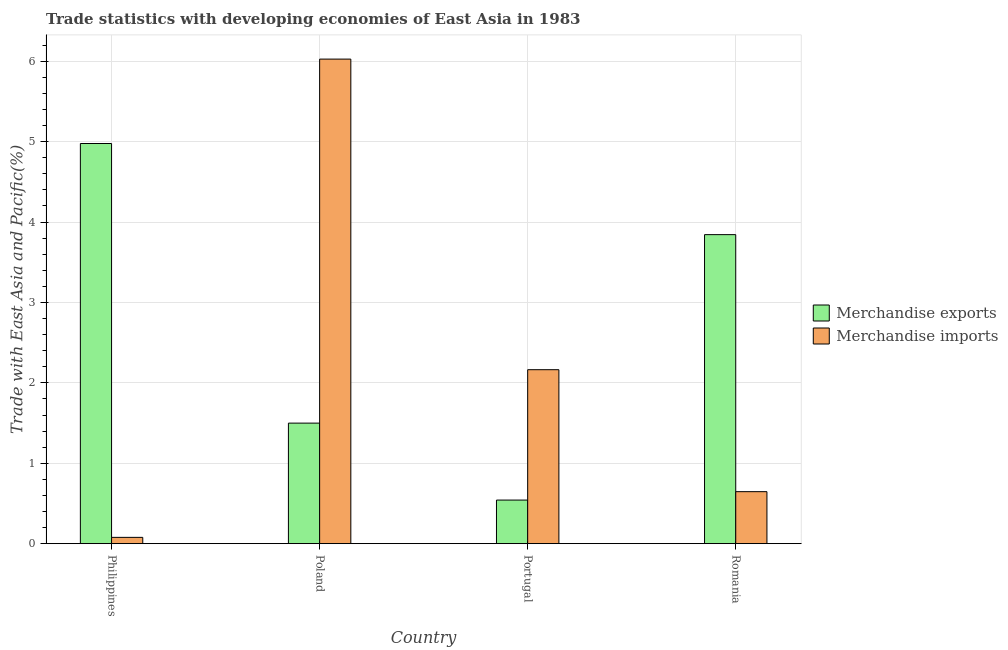How many groups of bars are there?
Make the answer very short. 4. Are the number of bars per tick equal to the number of legend labels?
Provide a short and direct response. Yes. Are the number of bars on each tick of the X-axis equal?
Offer a very short reply. Yes. How many bars are there on the 2nd tick from the left?
Offer a terse response. 2. How many bars are there on the 4th tick from the right?
Provide a short and direct response. 2. What is the merchandise imports in Poland?
Provide a short and direct response. 6.03. Across all countries, what is the maximum merchandise imports?
Give a very brief answer. 6.03. Across all countries, what is the minimum merchandise imports?
Provide a short and direct response. 0.08. In which country was the merchandise imports minimum?
Provide a short and direct response. Philippines. What is the total merchandise imports in the graph?
Keep it short and to the point. 8.91. What is the difference between the merchandise exports in Philippines and that in Poland?
Your answer should be compact. 3.48. What is the difference between the merchandise imports in Philippines and the merchandise exports in Romania?
Your response must be concise. -3.76. What is the average merchandise exports per country?
Your answer should be very brief. 2.72. What is the difference between the merchandise imports and merchandise exports in Portugal?
Make the answer very short. 1.62. In how many countries, is the merchandise exports greater than 0.8 %?
Give a very brief answer. 3. What is the ratio of the merchandise imports in Poland to that in Portugal?
Your answer should be very brief. 2.79. Is the difference between the merchandise exports in Philippines and Poland greater than the difference between the merchandise imports in Philippines and Poland?
Offer a very short reply. Yes. What is the difference between the highest and the second highest merchandise imports?
Your answer should be compact. 3.86. What is the difference between the highest and the lowest merchandise exports?
Your answer should be compact. 4.43. In how many countries, is the merchandise imports greater than the average merchandise imports taken over all countries?
Keep it short and to the point. 1. Is the sum of the merchandise imports in Philippines and Poland greater than the maximum merchandise exports across all countries?
Provide a short and direct response. Yes. What does the 2nd bar from the left in Philippines represents?
Your answer should be compact. Merchandise imports. What does the 2nd bar from the right in Portugal represents?
Make the answer very short. Merchandise exports. How many bars are there?
Make the answer very short. 8. Are all the bars in the graph horizontal?
Provide a short and direct response. No. What is the difference between two consecutive major ticks on the Y-axis?
Provide a short and direct response. 1. Where does the legend appear in the graph?
Provide a short and direct response. Center right. How many legend labels are there?
Give a very brief answer. 2. How are the legend labels stacked?
Give a very brief answer. Vertical. What is the title of the graph?
Your response must be concise. Trade statistics with developing economies of East Asia in 1983. What is the label or title of the X-axis?
Keep it short and to the point. Country. What is the label or title of the Y-axis?
Keep it short and to the point. Trade with East Asia and Pacific(%). What is the Trade with East Asia and Pacific(%) in Merchandise exports in Philippines?
Ensure brevity in your answer.  4.98. What is the Trade with East Asia and Pacific(%) of Merchandise imports in Philippines?
Your response must be concise. 0.08. What is the Trade with East Asia and Pacific(%) of Merchandise exports in Poland?
Your answer should be very brief. 1.5. What is the Trade with East Asia and Pacific(%) of Merchandise imports in Poland?
Provide a short and direct response. 6.03. What is the Trade with East Asia and Pacific(%) in Merchandise exports in Portugal?
Make the answer very short. 0.54. What is the Trade with East Asia and Pacific(%) in Merchandise imports in Portugal?
Provide a short and direct response. 2.16. What is the Trade with East Asia and Pacific(%) in Merchandise exports in Romania?
Ensure brevity in your answer.  3.84. What is the Trade with East Asia and Pacific(%) in Merchandise imports in Romania?
Your response must be concise. 0.65. Across all countries, what is the maximum Trade with East Asia and Pacific(%) in Merchandise exports?
Your answer should be very brief. 4.98. Across all countries, what is the maximum Trade with East Asia and Pacific(%) of Merchandise imports?
Provide a succinct answer. 6.03. Across all countries, what is the minimum Trade with East Asia and Pacific(%) in Merchandise exports?
Provide a short and direct response. 0.54. Across all countries, what is the minimum Trade with East Asia and Pacific(%) of Merchandise imports?
Ensure brevity in your answer.  0.08. What is the total Trade with East Asia and Pacific(%) in Merchandise exports in the graph?
Your answer should be compact. 10.86. What is the total Trade with East Asia and Pacific(%) in Merchandise imports in the graph?
Keep it short and to the point. 8.91. What is the difference between the Trade with East Asia and Pacific(%) of Merchandise exports in Philippines and that in Poland?
Make the answer very short. 3.48. What is the difference between the Trade with East Asia and Pacific(%) in Merchandise imports in Philippines and that in Poland?
Provide a short and direct response. -5.95. What is the difference between the Trade with East Asia and Pacific(%) of Merchandise exports in Philippines and that in Portugal?
Your answer should be compact. 4.43. What is the difference between the Trade with East Asia and Pacific(%) of Merchandise imports in Philippines and that in Portugal?
Give a very brief answer. -2.09. What is the difference between the Trade with East Asia and Pacific(%) of Merchandise exports in Philippines and that in Romania?
Your answer should be very brief. 1.13. What is the difference between the Trade with East Asia and Pacific(%) in Merchandise imports in Philippines and that in Romania?
Give a very brief answer. -0.57. What is the difference between the Trade with East Asia and Pacific(%) in Merchandise exports in Poland and that in Portugal?
Keep it short and to the point. 0.96. What is the difference between the Trade with East Asia and Pacific(%) in Merchandise imports in Poland and that in Portugal?
Offer a terse response. 3.86. What is the difference between the Trade with East Asia and Pacific(%) in Merchandise exports in Poland and that in Romania?
Your answer should be very brief. -2.34. What is the difference between the Trade with East Asia and Pacific(%) in Merchandise imports in Poland and that in Romania?
Keep it short and to the point. 5.38. What is the difference between the Trade with East Asia and Pacific(%) of Merchandise exports in Portugal and that in Romania?
Ensure brevity in your answer.  -3.3. What is the difference between the Trade with East Asia and Pacific(%) of Merchandise imports in Portugal and that in Romania?
Offer a terse response. 1.52. What is the difference between the Trade with East Asia and Pacific(%) of Merchandise exports in Philippines and the Trade with East Asia and Pacific(%) of Merchandise imports in Poland?
Your answer should be very brief. -1.05. What is the difference between the Trade with East Asia and Pacific(%) in Merchandise exports in Philippines and the Trade with East Asia and Pacific(%) in Merchandise imports in Portugal?
Keep it short and to the point. 2.81. What is the difference between the Trade with East Asia and Pacific(%) of Merchandise exports in Philippines and the Trade with East Asia and Pacific(%) of Merchandise imports in Romania?
Provide a short and direct response. 4.33. What is the difference between the Trade with East Asia and Pacific(%) of Merchandise exports in Poland and the Trade with East Asia and Pacific(%) of Merchandise imports in Portugal?
Offer a very short reply. -0.66. What is the difference between the Trade with East Asia and Pacific(%) of Merchandise exports in Poland and the Trade with East Asia and Pacific(%) of Merchandise imports in Romania?
Offer a very short reply. 0.85. What is the difference between the Trade with East Asia and Pacific(%) of Merchandise exports in Portugal and the Trade with East Asia and Pacific(%) of Merchandise imports in Romania?
Ensure brevity in your answer.  -0.1. What is the average Trade with East Asia and Pacific(%) in Merchandise exports per country?
Offer a terse response. 2.72. What is the average Trade with East Asia and Pacific(%) of Merchandise imports per country?
Make the answer very short. 2.23. What is the difference between the Trade with East Asia and Pacific(%) of Merchandise exports and Trade with East Asia and Pacific(%) of Merchandise imports in Philippines?
Keep it short and to the point. 4.9. What is the difference between the Trade with East Asia and Pacific(%) of Merchandise exports and Trade with East Asia and Pacific(%) of Merchandise imports in Poland?
Your response must be concise. -4.53. What is the difference between the Trade with East Asia and Pacific(%) of Merchandise exports and Trade with East Asia and Pacific(%) of Merchandise imports in Portugal?
Offer a very short reply. -1.62. What is the difference between the Trade with East Asia and Pacific(%) in Merchandise exports and Trade with East Asia and Pacific(%) in Merchandise imports in Romania?
Your response must be concise. 3.2. What is the ratio of the Trade with East Asia and Pacific(%) in Merchandise exports in Philippines to that in Poland?
Your response must be concise. 3.32. What is the ratio of the Trade with East Asia and Pacific(%) of Merchandise imports in Philippines to that in Poland?
Ensure brevity in your answer.  0.01. What is the ratio of the Trade with East Asia and Pacific(%) in Merchandise exports in Philippines to that in Portugal?
Give a very brief answer. 9.18. What is the ratio of the Trade with East Asia and Pacific(%) of Merchandise imports in Philippines to that in Portugal?
Make the answer very short. 0.04. What is the ratio of the Trade with East Asia and Pacific(%) of Merchandise exports in Philippines to that in Romania?
Make the answer very short. 1.29. What is the ratio of the Trade with East Asia and Pacific(%) in Merchandise imports in Philippines to that in Romania?
Give a very brief answer. 0.12. What is the ratio of the Trade with East Asia and Pacific(%) in Merchandise exports in Poland to that in Portugal?
Your answer should be compact. 2.77. What is the ratio of the Trade with East Asia and Pacific(%) of Merchandise imports in Poland to that in Portugal?
Offer a terse response. 2.79. What is the ratio of the Trade with East Asia and Pacific(%) in Merchandise exports in Poland to that in Romania?
Make the answer very short. 0.39. What is the ratio of the Trade with East Asia and Pacific(%) of Merchandise imports in Poland to that in Romania?
Provide a short and direct response. 9.32. What is the ratio of the Trade with East Asia and Pacific(%) in Merchandise exports in Portugal to that in Romania?
Your answer should be very brief. 0.14. What is the ratio of the Trade with East Asia and Pacific(%) of Merchandise imports in Portugal to that in Romania?
Make the answer very short. 3.35. What is the difference between the highest and the second highest Trade with East Asia and Pacific(%) of Merchandise exports?
Provide a short and direct response. 1.13. What is the difference between the highest and the second highest Trade with East Asia and Pacific(%) in Merchandise imports?
Your answer should be compact. 3.86. What is the difference between the highest and the lowest Trade with East Asia and Pacific(%) in Merchandise exports?
Your response must be concise. 4.43. What is the difference between the highest and the lowest Trade with East Asia and Pacific(%) in Merchandise imports?
Offer a terse response. 5.95. 